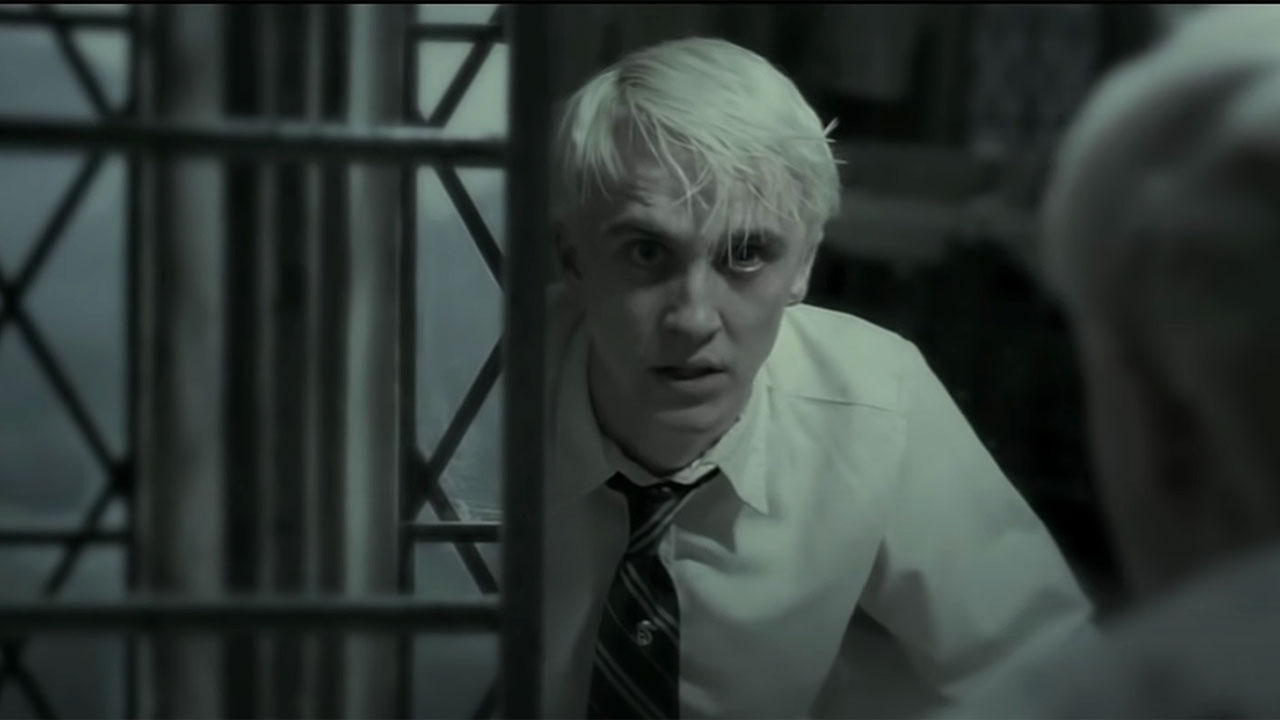Can you imagine a different, non-Harry Potter related story behind this image? Certainly! Let's imagine an alternate story. Draco, in this image, is no longer a wizard of Hogwarts. Instead, he's a young scientist in a dystopian future, working on a secret experiment involving the manipulation of time. The metal bars are part of a time chamber he created, which is now malfunctioning. His shocked expression reflects the sudden realization that the experiment has gone terribly wrong, and he's witnessing the catastrophic consequences unfold. Perhaps he's seeing a glimpse of a parallel universe, where his life took a dark turn, or maybe the experiment has triggered a time fracture that threatens to collapse his entire reality. 